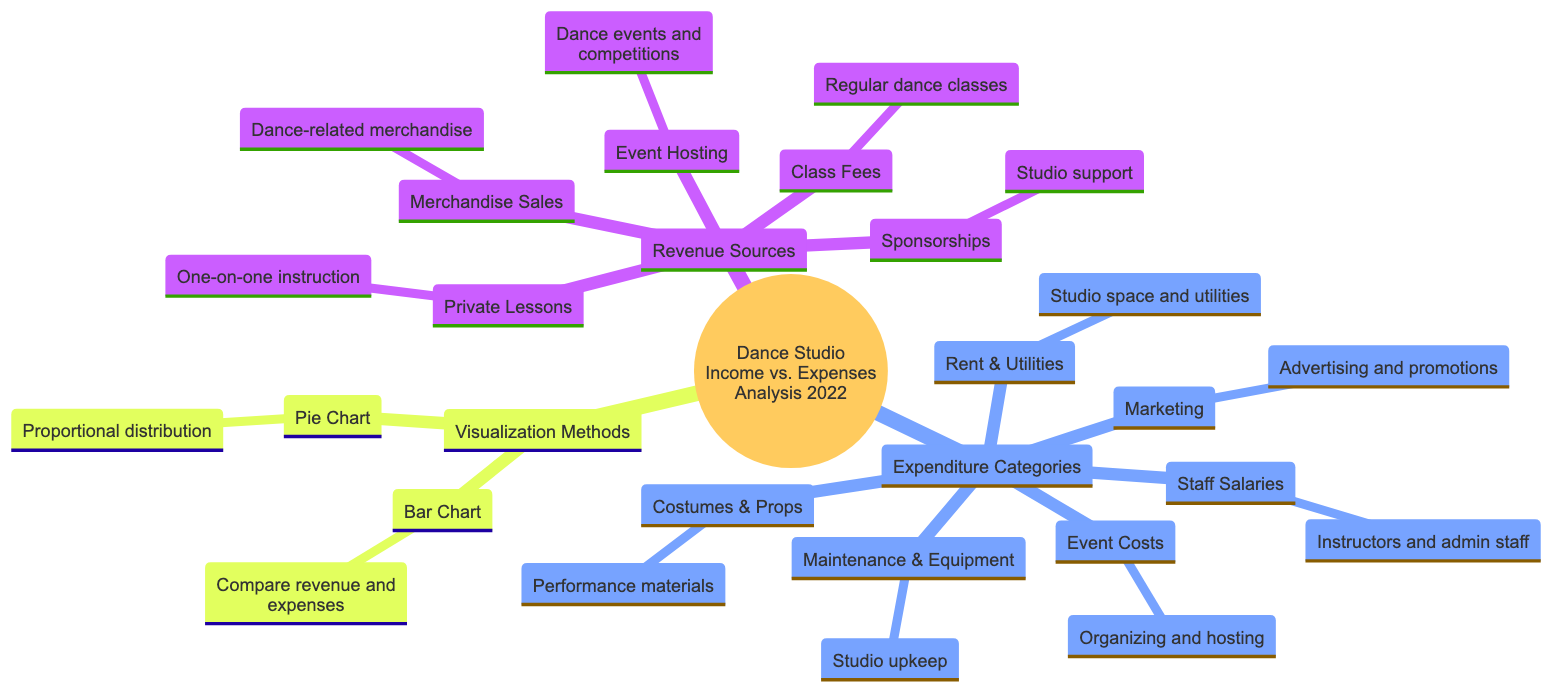What are the main sources of revenue for the dance studio? The diagram lists five revenue sources: Class Fees, Event Hosting, Merchandise Sales, Sponsorships, and Private Lessons. These are found under the "Revenue Sources" section.
Answer: Class Fees, Event Hosting, Merchandise Sales, Sponsorships, Private Lessons Which category constitutes the largest expense for the studio? The diagram displays six expenditure categories without specific values; however, based on common studio operations, typically "Staff Salaries" is a major expense. It is found in the "Expenditure Categories" section.
Answer: Staff Salaries How many total revenue sources are indicated in the diagram? The diagram lists a total of five revenue sources (Class Fees, Event Hosting, Merchandise Sales, Sponsorships, and Private Lessons). Counting these provides the answer.
Answer: 5 What type of chart is used to compare revenue and expenses? The diagram specifies that a bar chart is used for comparing revenue and expenses in the "Visualization Methods" section.
Answer: Bar Chart Which expenditure category includes costs for advertising? The diagram specifies "Marketing" as the category related to advertising and promotions under "Expenditure Categories".
Answer: Marketing Which revenue source is related to one-on-one instruction? The diagram indicates "Private Lessons" as the revenue source that pertains to one-on-one instruction, found within the "Revenue Sources" section.
Answer: Private Lessons What visualization method shows the proportional distribution of income and expenditures? The diagram mentions a pie chart for the proportional distribution of categories, under "Visualization Methods".
Answer: Pie Chart How many total categories of expenditures does the diagram display? The diagram lists six expenditure categories: Rent & Utilities, Staff Salaries, Costumes & Props, Marketing, Event Costs, and Maintenance & Equipment, totaling to six categories.
Answer: 6 Which revenue source is depicted as related to hosting events? The diagram identifies "Event Hosting" as the revenue source for hosting dance events and competitions, found under "Revenue Sources".
Answer: Event Hosting What does the term "Sponsorships" refer to in this context? In the diagram, "Sponsorships" refers to studio support, listed as one of the revenue sources. This indicates financial backing from external organizations.
Answer: Studio support 